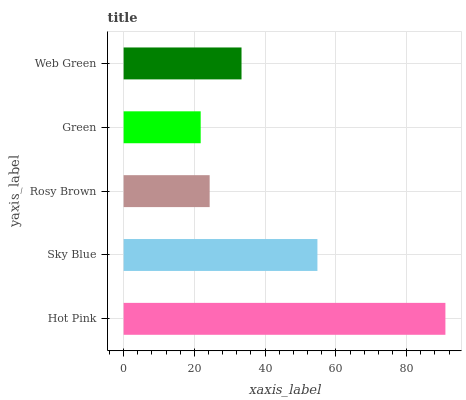Is Green the minimum?
Answer yes or no. Yes. Is Hot Pink the maximum?
Answer yes or no. Yes. Is Sky Blue the minimum?
Answer yes or no. No. Is Sky Blue the maximum?
Answer yes or no. No. Is Hot Pink greater than Sky Blue?
Answer yes or no. Yes. Is Sky Blue less than Hot Pink?
Answer yes or no. Yes. Is Sky Blue greater than Hot Pink?
Answer yes or no. No. Is Hot Pink less than Sky Blue?
Answer yes or no. No. Is Web Green the high median?
Answer yes or no. Yes. Is Web Green the low median?
Answer yes or no. Yes. Is Sky Blue the high median?
Answer yes or no. No. Is Sky Blue the low median?
Answer yes or no. No. 